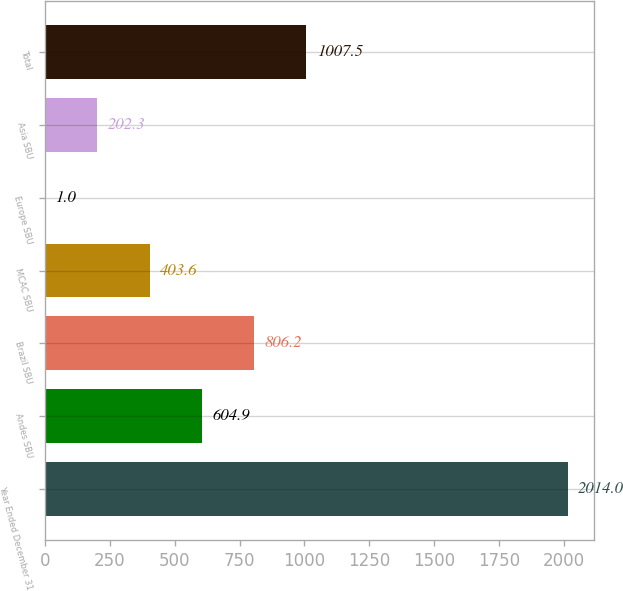<chart> <loc_0><loc_0><loc_500><loc_500><bar_chart><fcel>Year Ended December 31<fcel>Andes SBU<fcel>Brazil SBU<fcel>MCAC SBU<fcel>Europe SBU<fcel>Asia SBU<fcel>Total<nl><fcel>2014<fcel>604.9<fcel>806.2<fcel>403.6<fcel>1<fcel>202.3<fcel>1007.5<nl></chart> 